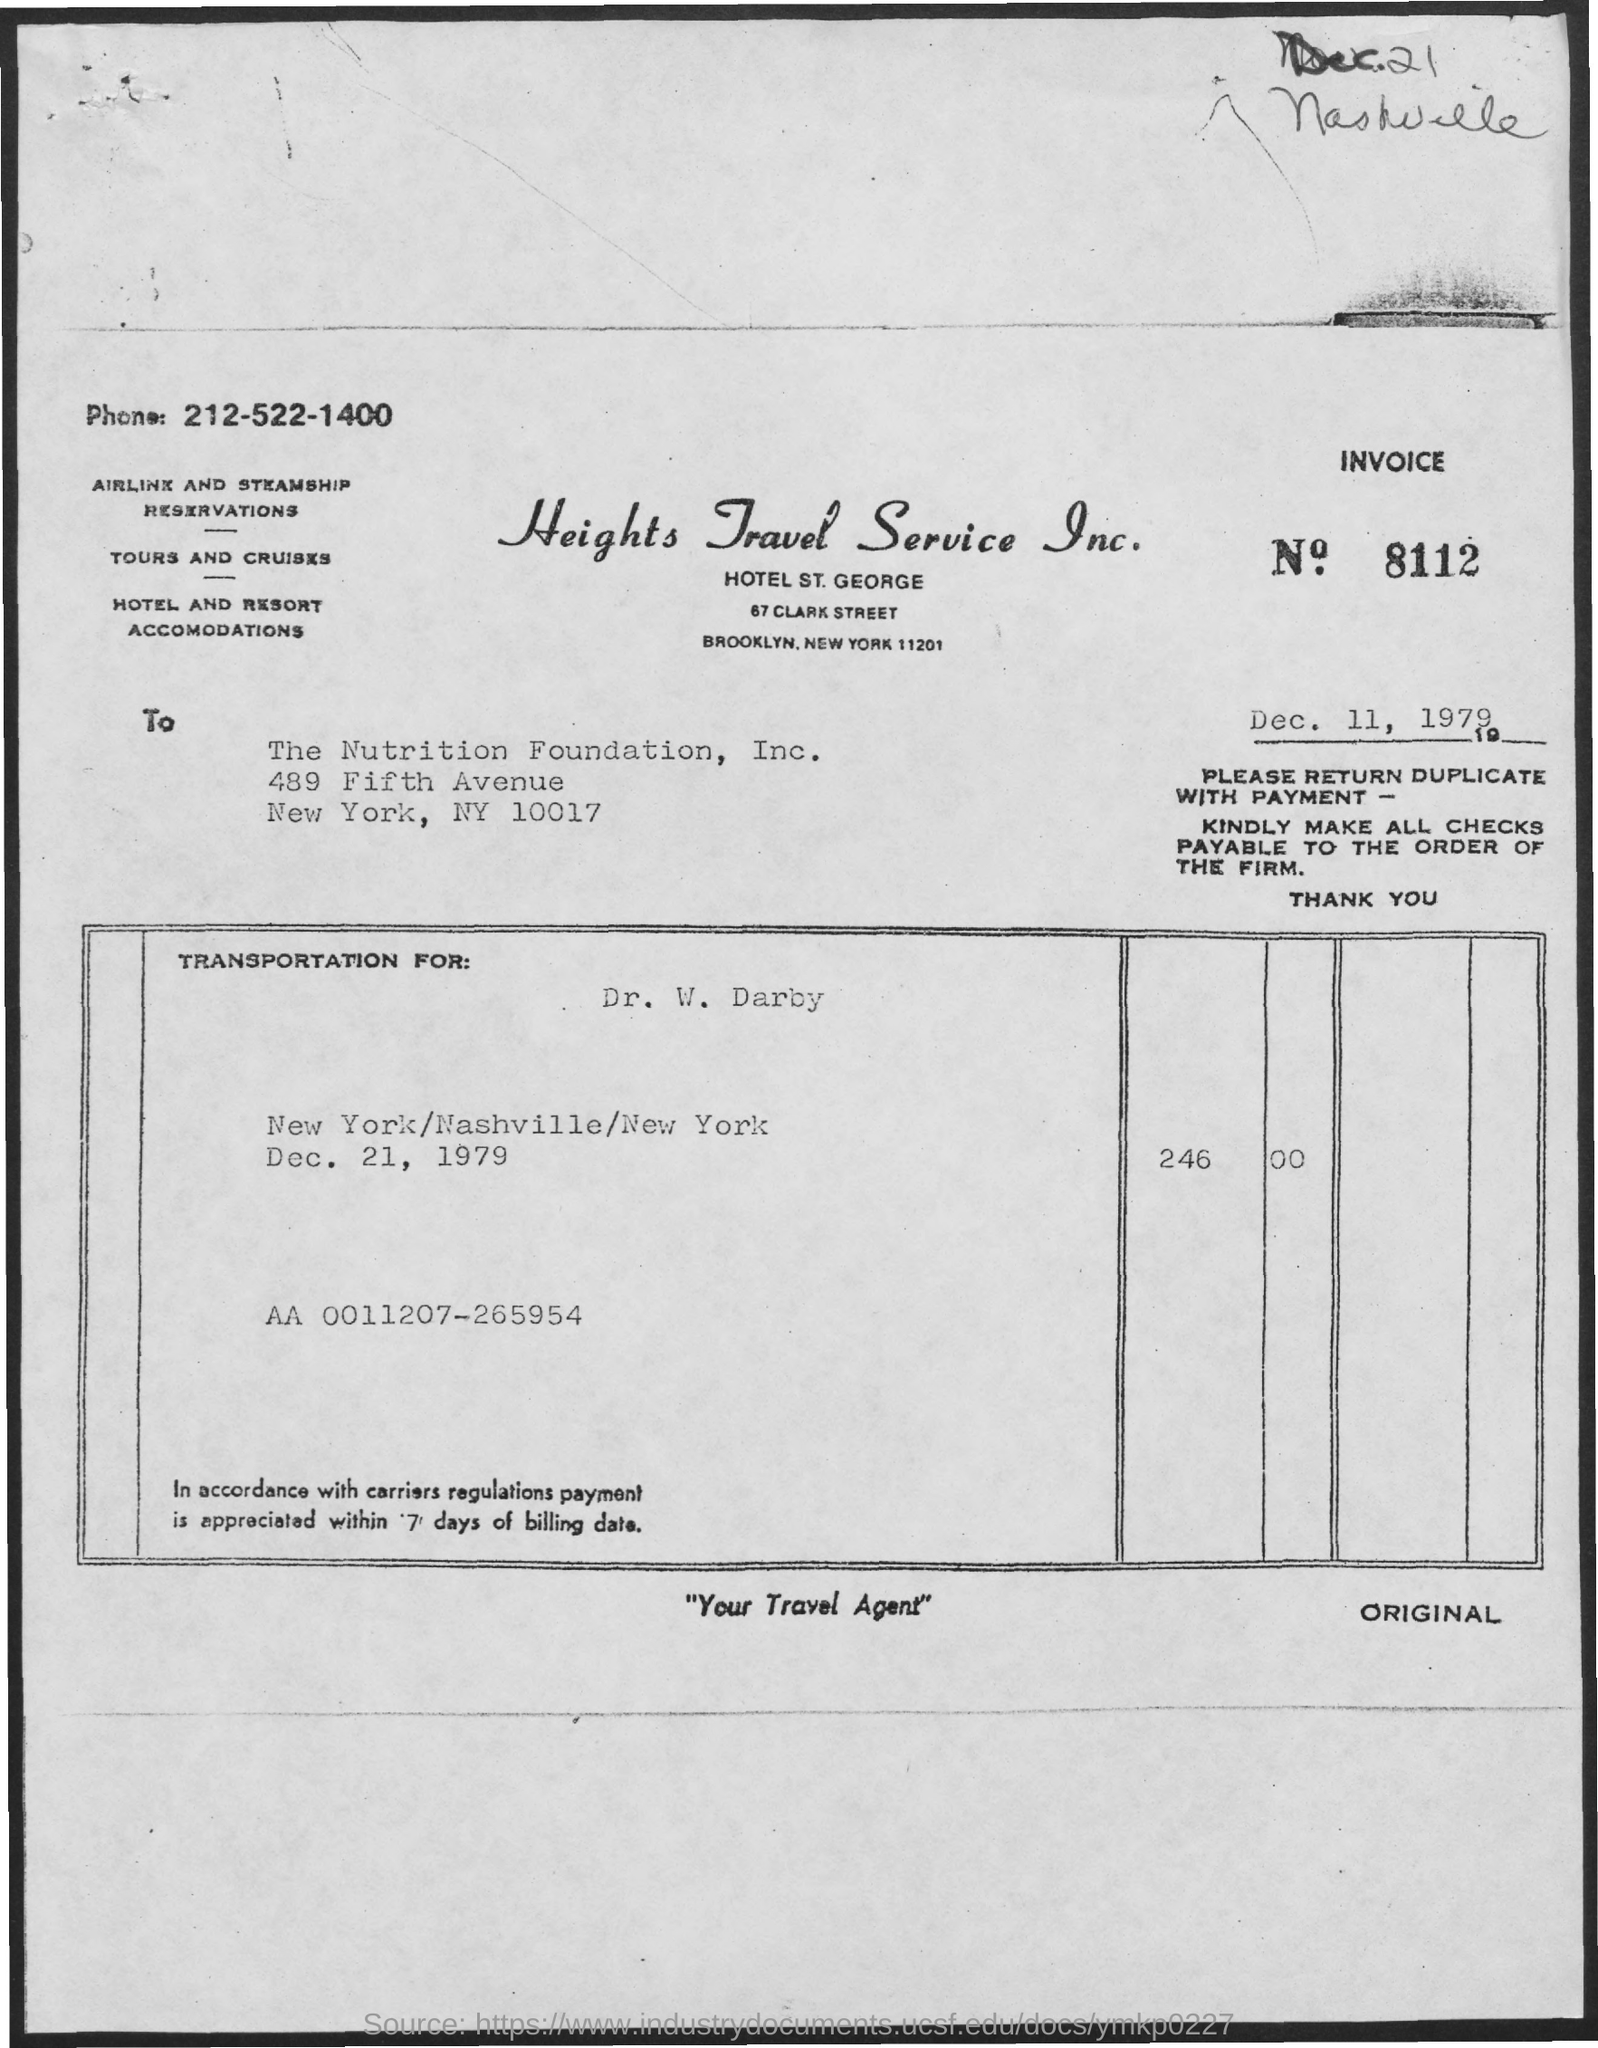What is the Invoice No mentioned in this document?
Offer a very short reply. 8112. What is the issued date of the invoice?
Ensure brevity in your answer.  Dec. 11, 1979. To whom, the invoice is addressed?
Ensure brevity in your answer.  The nutrition foundation, inc. What is the phone no of Heights Travel Service Inc. given?
Offer a very short reply. 212-522-1400. Which company is raising the invoice?
Make the answer very short. Heights travel service inc. What is the invoice amount on transportation for Dr. W. Darby dated Dec. 21, 1979?
Give a very brief answer. 246 00. 